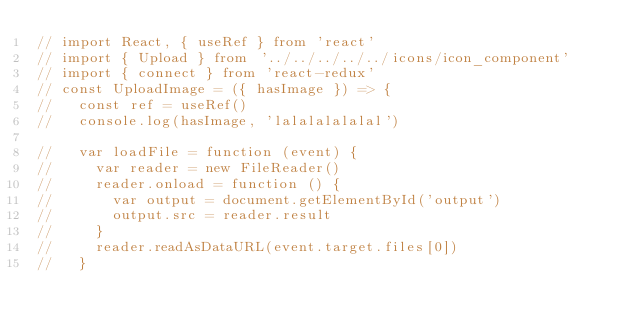<code> <loc_0><loc_0><loc_500><loc_500><_JavaScript_>// import React, { useRef } from 'react'
// import { Upload } from '../../../../../icons/icon_component'
// import { connect } from 'react-redux'
// const UploadImage = ({ hasImage }) => {
//   const ref = useRef()
//   console.log(hasImage, 'lalalalalalal')

//   var loadFile = function (event) {
//     var reader = new FileReader()
//     reader.onload = function () {
//       var output = document.getElementById('output')
//       output.src = reader.result
//     }
//     reader.readAsDataURL(event.target.files[0])
//   }</code> 